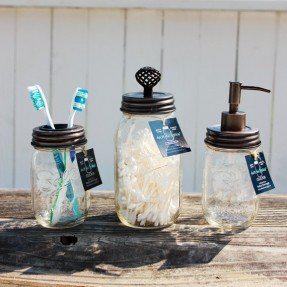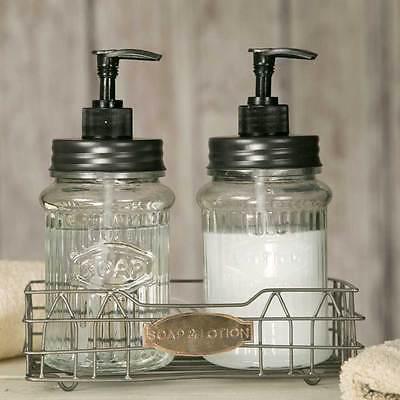The first image is the image on the left, the second image is the image on the right. Analyze the images presented: Is the assertion "The left image contains exactly two glass jar dispensers." valid? Answer yes or no. No. The first image is the image on the left, the second image is the image on the right. Analyze the images presented: Is the assertion "An image shows a pair of pump-top dispensers in a wire caddy with an oval medallion on the front, and the other image includes a jar of toothbrushes." valid? Answer yes or no. Yes. 